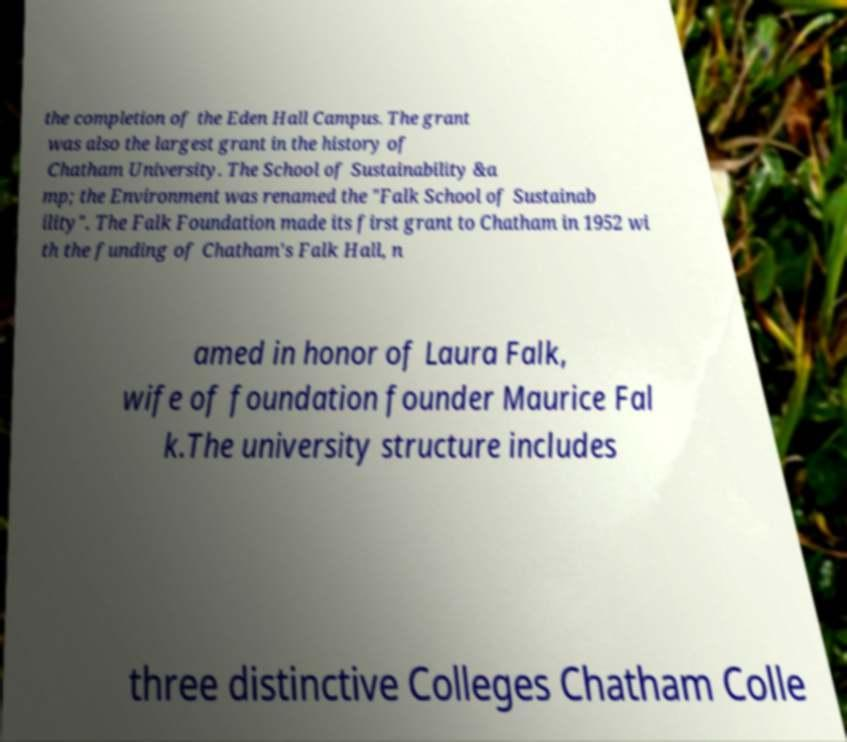Can you accurately transcribe the text from the provided image for me? the completion of the Eden Hall Campus. The grant was also the largest grant in the history of Chatham University. The School of Sustainability &a mp; the Environment was renamed the "Falk School of Sustainab ility". The Falk Foundation made its first grant to Chatham in 1952 wi th the funding of Chatham's Falk Hall, n amed in honor of Laura Falk, wife of foundation founder Maurice Fal k.The university structure includes three distinctive Colleges Chatham Colle 